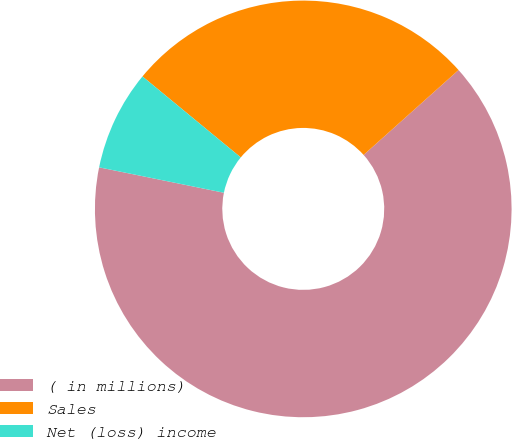<chart> <loc_0><loc_0><loc_500><loc_500><pie_chart><fcel>( in millions)<fcel>Sales<fcel>Net (loss) income<nl><fcel>64.81%<fcel>27.42%<fcel>7.77%<nl></chart> 